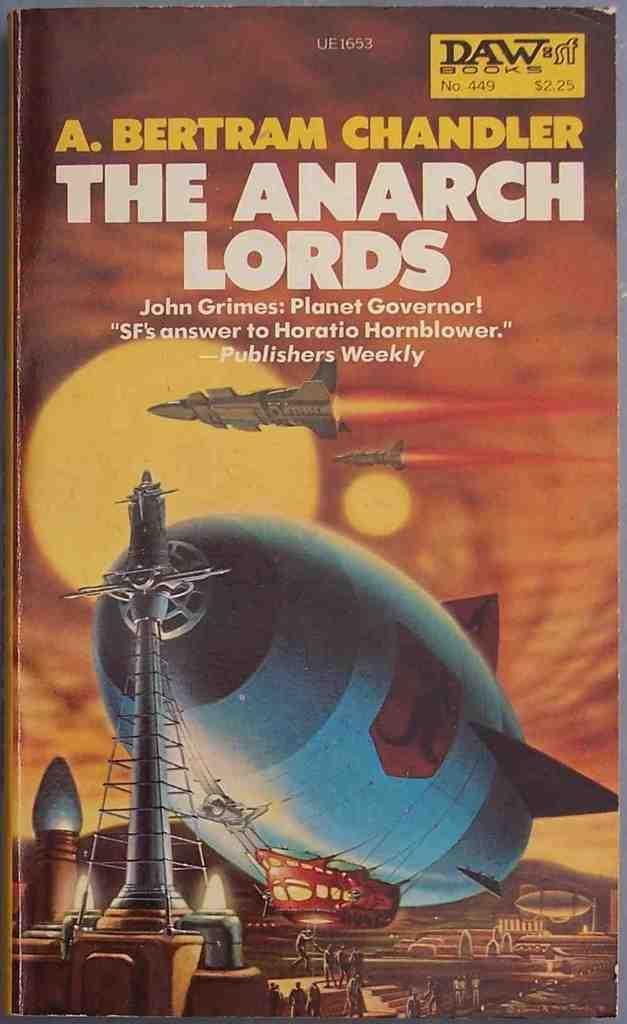<image>
Present a compact description of the photo's key features. A book called The Anarch Lords features a big blue blimp on the cover. 